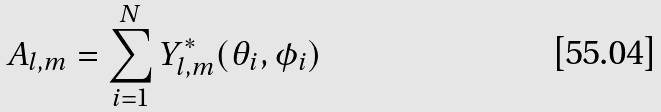Convert formula to latex. <formula><loc_0><loc_0><loc_500><loc_500>A _ { l , m } = \sum _ { i = 1 } ^ { N } Y _ { l , m } ^ { * } ( \theta _ { i } , \phi _ { i } )</formula> 